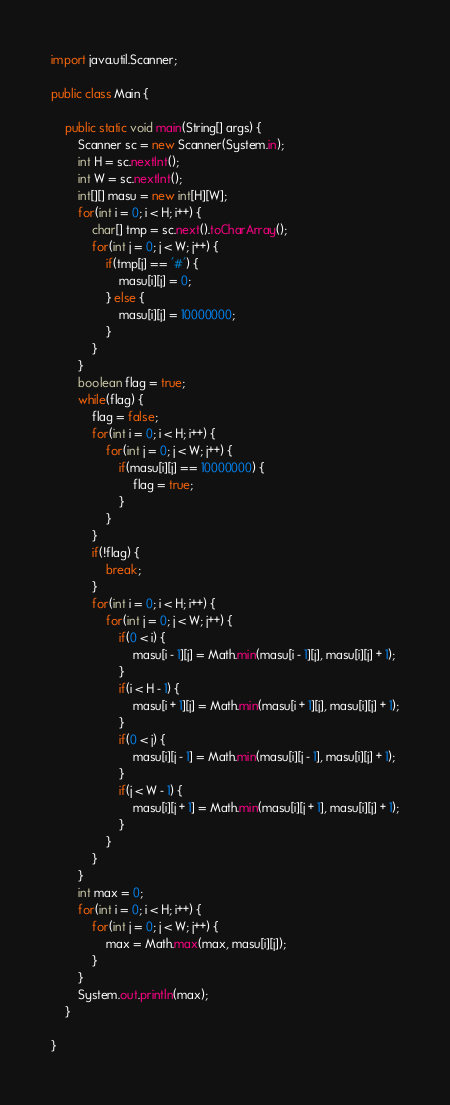Convert code to text. <code><loc_0><loc_0><loc_500><loc_500><_Java_>
import java.util.Scanner;

public class Main {

	public static void main(String[] args) {
		Scanner sc = new Scanner(System.in);
		int H = sc.nextInt();
		int W = sc.nextInt();
		int[][] masu = new int[H][W];
		for(int i = 0; i < H; i++) {
			char[] tmp = sc.next().toCharArray();
			for(int j = 0; j < W; j++) {
				if(tmp[j] == '#') {
					masu[i][j] = 0;
				} else {
					masu[i][j] = 10000000;
				}
			}
		}
		boolean flag = true;
		while(flag) {
			flag = false;
			for(int i = 0; i < H; i++) {
				for(int j = 0; j < W; j++) {
					if(masu[i][j] == 10000000) {
						flag = true;
					}
				}
			}
			if(!flag) {
				break;
			}
			for(int i = 0; i < H; i++) {
				for(int j = 0; j < W; j++) {
					if(0 < i) {
						masu[i - 1][j] = Math.min(masu[i - 1][j], masu[i][j] + 1);
					}
					if(i < H - 1) {
						masu[i + 1][j] = Math.min(masu[i + 1][j], masu[i][j] + 1);
					}
					if(0 < j) {
						masu[i][j - 1] = Math.min(masu[i][j - 1], masu[i][j] + 1);
					}
					if(j < W - 1) {
						masu[i][j + 1] = Math.min(masu[i][j + 1], masu[i][j] + 1);
					}
				}
			}
		}
		int max = 0;
		for(int i = 0; i < H; i++) {
			for(int j = 0; j < W; j++) {
				max = Math.max(max, masu[i][j]);
			}
		}
		System.out.println(max);
	}

}
</code> 